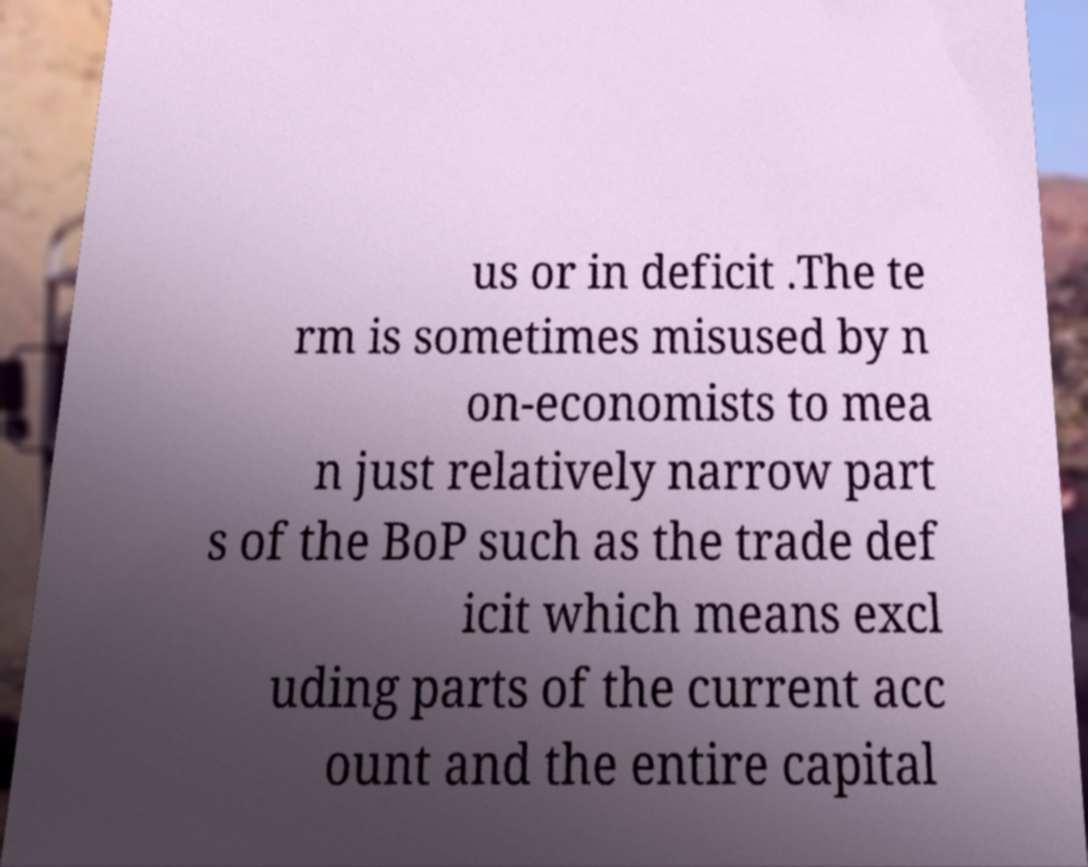Please identify and transcribe the text found in this image. us or in deficit .The te rm is sometimes misused by n on-economists to mea n just relatively narrow part s of the BoP such as the trade def icit which means excl uding parts of the current acc ount and the entire capital 